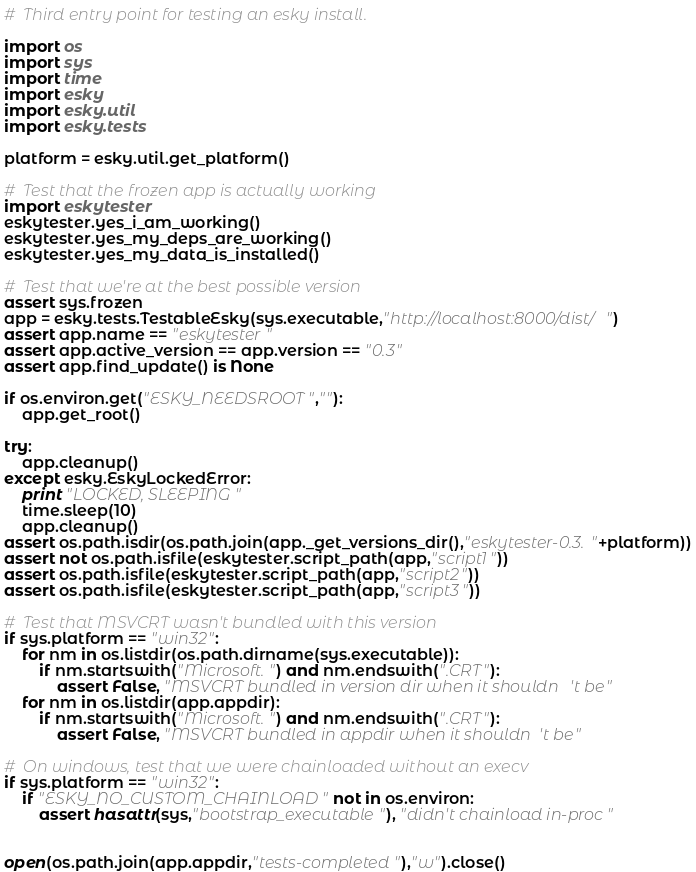Convert code to text. <code><loc_0><loc_0><loc_500><loc_500><_Python_>
#  Third entry point for testing an esky install.

import os
import sys
import time
import esky
import esky.util
import esky.tests

platform = esky.util.get_platform()

#  Test that the frozen app is actually working
import eskytester
eskytester.yes_i_am_working()
eskytester.yes_my_deps_are_working()
eskytester.yes_my_data_is_installed()

#  Test that we're at the best possible version
assert sys.frozen
app = esky.tests.TestableEsky(sys.executable,"http://localhost:8000/dist/")
assert app.name == "eskytester"
assert app.active_version == app.version == "0.3"
assert app.find_update() is None

if os.environ.get("ESKY_NEEDSROOT",""):
    app.get_root()

try:
    app.cleanup()
except esky.EskyLockedError:
    print "LOCKED, SLEEPING"
    time.sleep(10)
    app.cleanup()
assert os.path.isdir(os.path.join(app._get_versions_dir(),"eskytester-0.3."+platform))
assert not os.path.isfile(eskytester.script_path(app,"script1"))
assert os.path.isfile(eskytester.script_path(app,"script2"))
assert os.path.isfile(eskytester.script_path(app,"script3"))

#  Test that MSVCRT wasn't bundled with this version
if sys.platform == "win32":
    for nm in os.listdir(os.path.dirname(sys.executable)):
        if nm.startswith("Microsoft.") and nm.endswith(".CRT"):
            assert False, "MSVCRT bundled in version dir when it shouldn't be"
    for nm in os.listdir(app.appdir):
        if nm.startswith("Microsoft.") and nm.endswith(".CRT"):
            assert False, "MSVCRT bundled in appdir when it shouldn't be"

#  On windows, test that we were chainloaded without an execv
if sys.platform == "win32":
    if "ESKY_NO_CUSTOM_CHAINLOAD" not in os.environ:
        assert hasattr(sys,"bootstrap_executable"), "didn't chainload in-proc"


open(os.path.join(app.appdir,"tests-completed"),"w").close()
</code> 